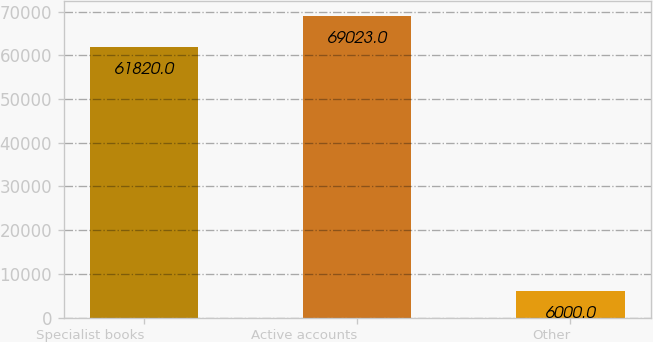<chart> <loc_0><loc_0><loc_500><loc_500><bar_chart><fcel>Specialist books<fcel>Active accounts<fcel>Other<nl><fcel>61820<fcel>69023<fcel>6000<nl></chart> 